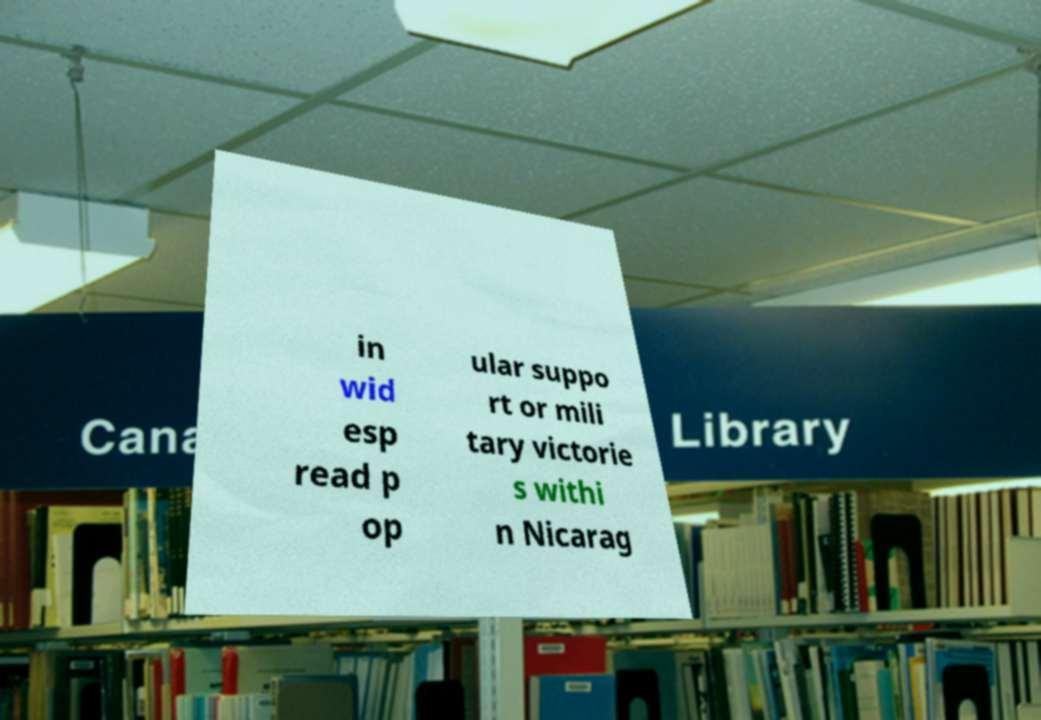Please read and relay the text visible in this image. What does it say? in wid esp read p op ular suppo rt or mili tary victorie s withi n Nicarag 